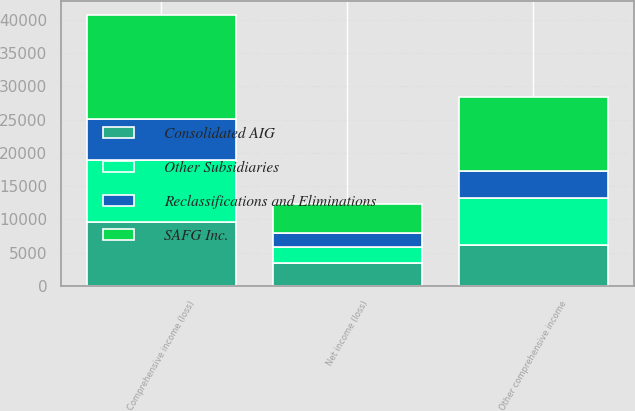<chart> <loc_0><loc_0><loc_500><loc_500><stacked_bar_chart><ecel><fcel>Net income (loss)<fcel>Other comprehensive income<fcel>Comprehensive income (loss)<nl><fcel>Consolidated AIG<fcel>3438<fcel>6093<fcel>9531<nl><fcel>Reclassifications and Eliminations<fcel>2207<fcel>3973<fcel>6180<nl><fcel>Other Subsidiaries<fcel>2340<fcel>7158<fcel>9441<nl><fcel>SAFG Inc.<fcel>4285<fcel>11128<fcel>15621<nl></chart> 